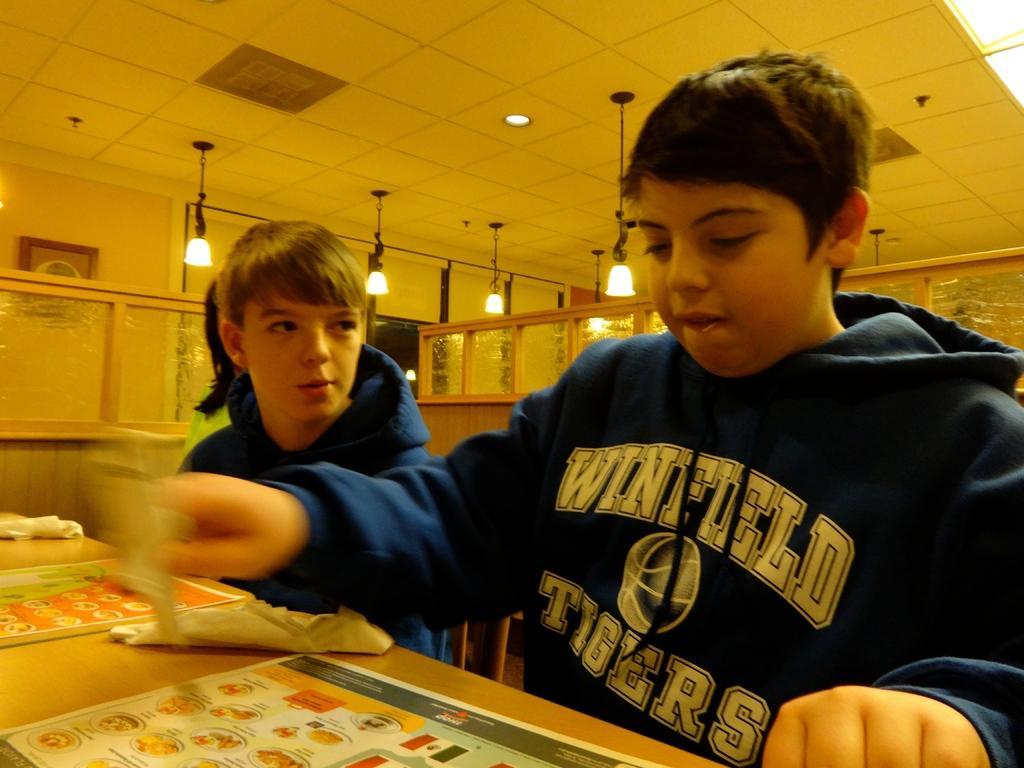Describe this image in one or two sentences. In this image in front there are two people sitting on the chairs. In front of the chairs there is a table. On top of the table there are tissues, menu cards. In the background of the image there is a partition. On top of the image there are lights. On the left side of the image there is a photo frame on the wall. 